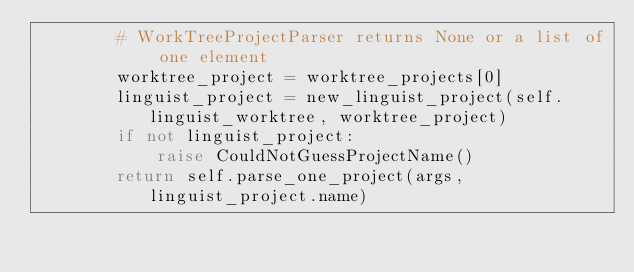<code> <loc_0><loc_0><loc_500><loc_500><_Python_>        # WorkTreeProjectParser returns None or a list of one element
        worktree_project = worktree_projects[0]
        linguist_project = new_linguist_project(self.linguist_worktree, worktree_project)
        if not linguist_project:
            raise CouldNotGuessProjectName()
        return self.parse_one_project(args, linguist_project.name)
</code> 